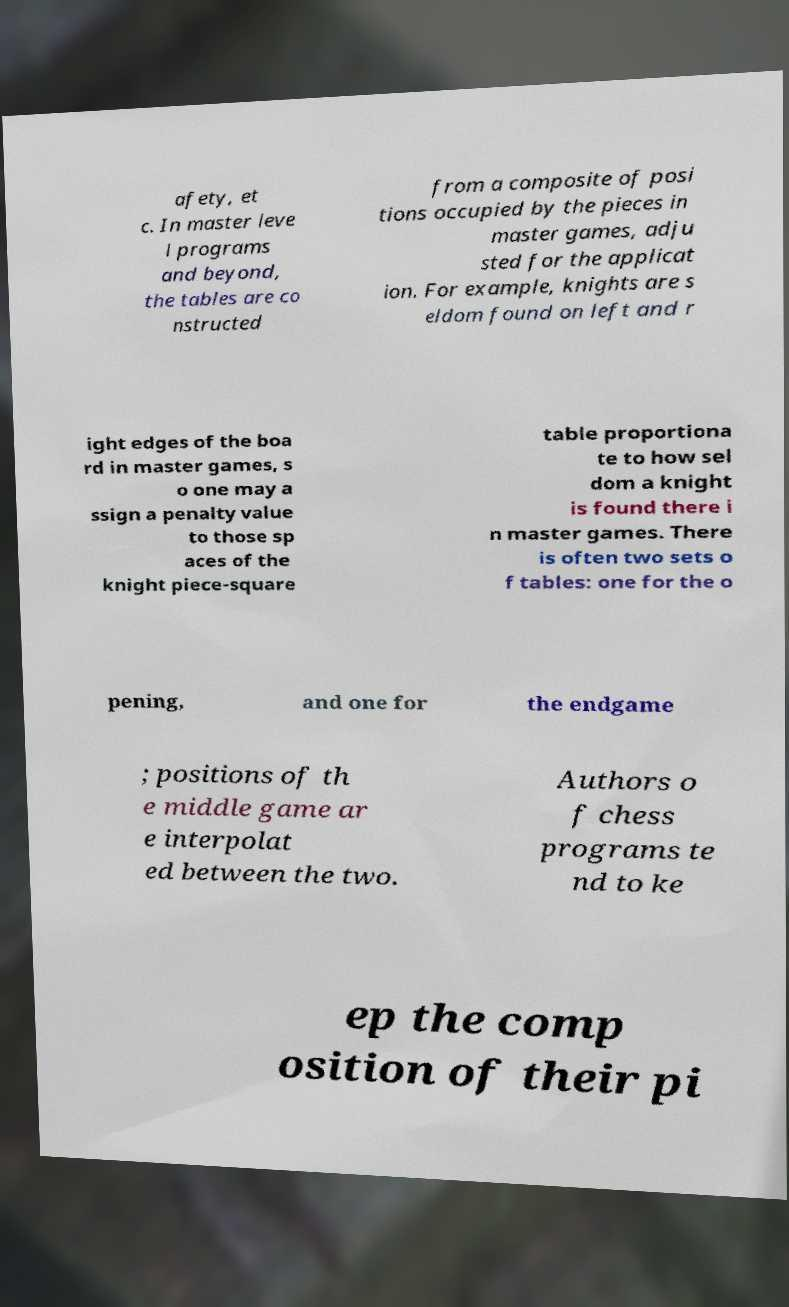I need the written content from this picture converted into text. Can you do that? afety, et c. In master leve l programs and beyond, the tables are co nstructed from a composite of posi tions occupied by the pieces in master games, adju sted for the applicat ion. For example, knights are s eldom found on left and r ight edges of the boa rd in master games, s o one may a ssign a penalty value to those sp aces of the knight piece-square table proportiona te to how sel dom a knight is found there i n master games. There is often two sets o f tables: one for the o pening, and one for the endgame ; positions of th e middle game ar e interpolat ed between the two. Authors o f chess programs te nd to ke ep the comp osition of their pi 